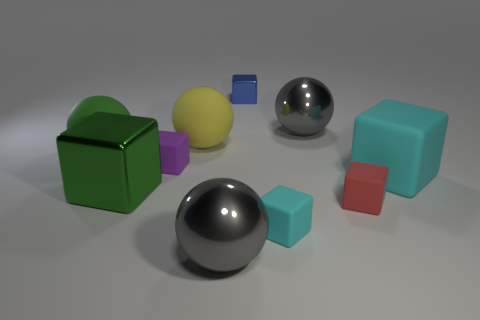What number of metal objects are tiny blue objects or cyan cubes?
Keep it short and to the point. 1. The thing that is the same color as the big rubber block is what shape?
Give a very brief answer. Cube. How many gray spheres are there?
Keep it short and to the point. 2. Does the yellow object that is right of the green rubber object have the same material as the cyan cube left of the big cyan matte block?
Offer a terse response. Yes. The purple object that is the same material as the big yellow object is what size?
Your answer should be very brief. Small. There is a shiny thing that is in front of the small cyan block; what shape is it?
Ensure brevity in your answer.  Sphere. There is a shiny ball that is behind the small red rubber cube; is its color the same as the big ball that is in front of the purple thing?
Give a very brief answer. Yes. There is a matte thing that is the same color as the large metal cube; what is its size?
Give a very brief answer. Large. Is there a small red rubber object?
Your answer should be compact. Yes. What is the shape of the big gray metallic object in front of the big green thing behind the green thing in front of the purple object?
Offer a terse response. Sphere. 